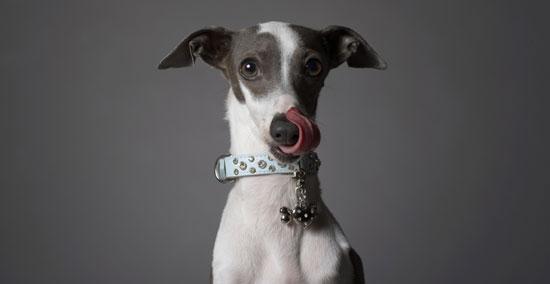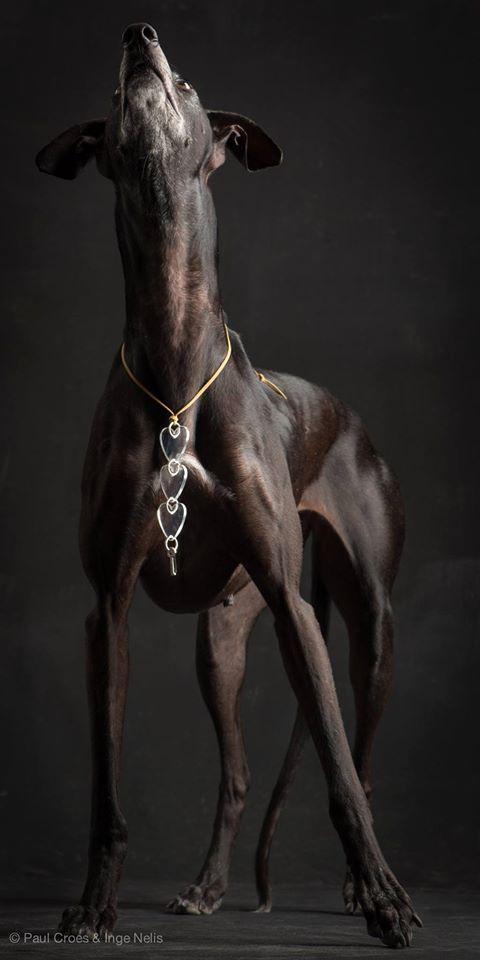The first image is the image on the left, the second image is the image on the right. Considering the images on both sides, is "A dog with a collar is looking at the camera in the image on the left." valid? Answer yes or no. Yes. The first image is the image on the left, the second image is the image on the right. Assess this claim about the two images: "An image contains a thin dark dog that is looking towards the right.". Correct or not? Answer yes or no. No. 